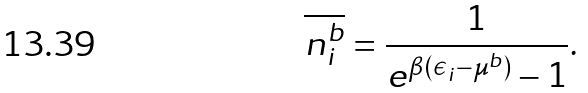<formula> <loc_0><loc_0><loc_500><loc_500>\overline { n _ { i } ^ { b } } = \frac { 1 } { e ^ { \beta ( \epsilon _ { i } - \mu ^ { b } ) } - 1 } .</formula> 